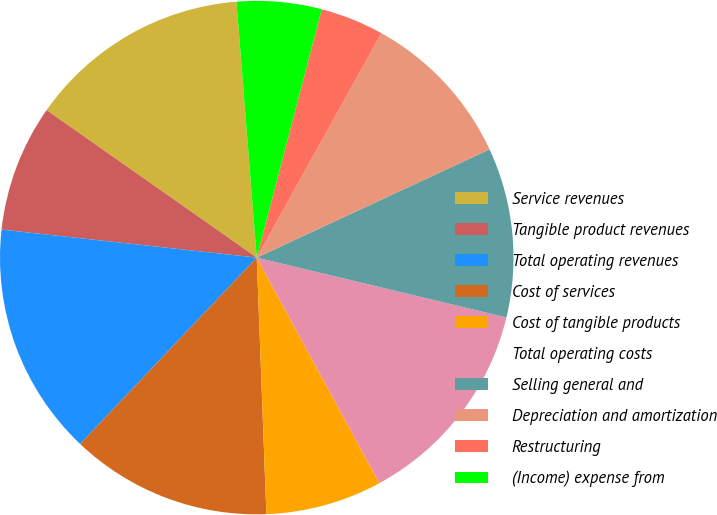<chart> <loc_0><loc_0><loc_500><loc_500><pie_chart><fcel>Service revenues<fcel>Tangible product revenues<fcel>Total operating revenues<fcel>Cost of services<fcel>Cost of tangible products<fcel>Total operating costs<fcel>Selling general and<fcel>Depreciation and amortization<fcel>Restructuring<fcel>(Income) expense from<nl><fcel>14.0%<fcel>8.0%<fcel>14.67%<fcel>12.67%<fcel>7.33%<fcel>13.33%<fcel>10.67%<fcel>10.0%<fcel>4.0%<fcel>5.33%<nl></chart> 